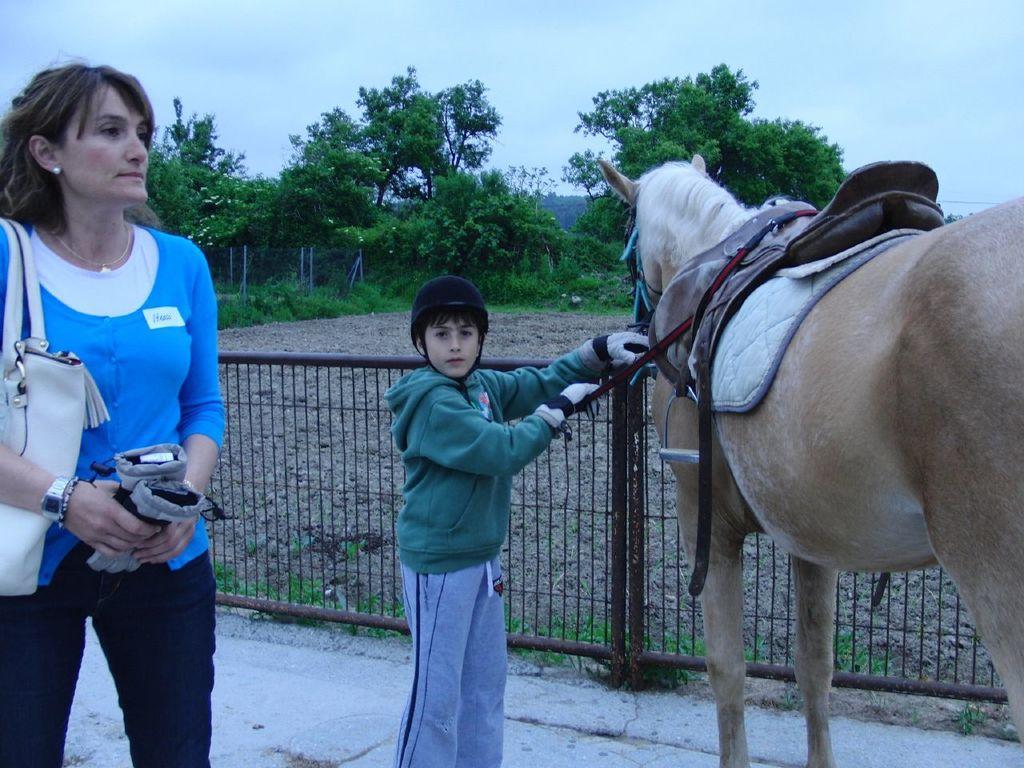Describe this image in one or two sentences. Here we can see a woman on the left side with handbag in her land and the kid holding the horse and behind them we can see trees 